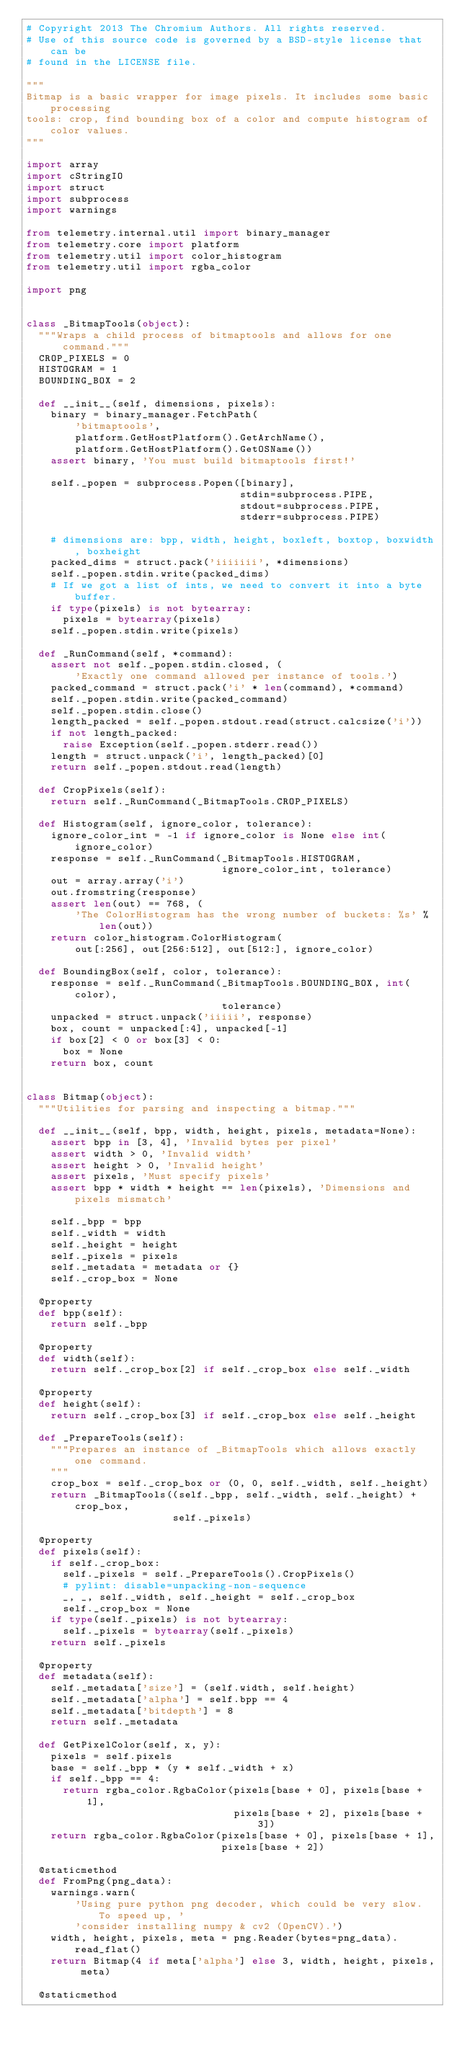<code> <loc_0><loc_0><loc_500><loc_500><_Python_># Copyright 2013 The Chromium Authors. All rights reserved.
# Use of this source code is governed by a BSD-style license that can be
# found in the LICENSE file.

"""
Bitmap is a basic wrapper for image pixels. It includes some basic processing
tools: crop, find bounding box of a color and compute histogram of color values.
"""

import array
import cStringIO
import struct
import subprocess
import warnings

from telemetry.internal.util import binary_manager
from telemetry.core import platform
from telemetry.util import color_histogram
from telemetry.util import rgba_color

import png


class _BitmapTools(object):
  """Wraps a child process of bitmaptools and allows for one command."""
  CROP_PIXELS = 0
  HISTOGRAM = 1
  BOUNDING_BOX = 2

  def __init__(self, dimensions, pixels):
    binary = binary_manager.FetchPath(
        'bitmaptools',
        platform.GetHostPlatform().GetArchName(),
        platform.GetHostPlatform().GetOSName())
    assert binary, 'You must build bitmaptools first!'

    self._popen = subprocess.Popen([binary],
                                   stdin=subprocess.PIPE,
                                   stdout=subprocess.PIPE,
                                   stderr=subprocess.PIPE)

    # dimensions are: bpp, width, height, boxleft, boxtop, boxwidth, boxheight
    packed_dims = struct.pack('iiiiiii', *dimensions)
    self._popen.stdin.write(packed_dims)
    # If we got a list of ints, we need to convert it into a byte buffer.
    if type(pixels) is not bytearray:
      pixels = bytearray(pixels)
    self._popen.stdin.write(pixels)

  def _RunCommand(self, *command):
    assert not self._popen.stdin.closed, (
        'Exactly one command allowed per instance of tools.')
    packed_command = struct.pack('i' * len(command), *command)
    self._popen.stdin.write(packed_command)
    self._popen.stdin.close()
    length_packed = self._popen.stdout.read(struct.calcsize('i'))
    if not length_packed:
      raise Exception(self._popen.stderr.read())
    length = struct.unpack('i', length_packed)[0]
    return self._popen.stdout.read(length)

  def CropPixels(self):
    return self._RunCommand(_BitmapTools.CROP_PIXELS)

  def Histogram(self, ignore_color, tolerance):
    ignore_color_int = -1 if ignore_color is None else int(ignore_color)
    response = self._RunCommand(_BitmapTools.HISTOGRAM,
                                ignore_color_int, tolerance)
    out = array.array('i')
    out.fromstring(response)
    assert len(out) == 768, (
        'The ColorHistogram has the wrong number of buckets: %s' % len(out))
    return color_histogram.ColorHistogram(
        out[:256], out[256:512], out[512:], ignore_color)

  def BoundingBox(self, color, tolerance):
    response = self._RunCommand(_BitmapTools.BOUNDING_BOX, int(color),
                                tolerance)
    unpacked = struct.unpack('iiiii', response)
    box, count = unpacked[:4], unpacked[-1]
    if box[2] < 0 or box[3] < 0:
      box = None
    return box, count


class Bitmap(object):
  """Utilities for parsing and inspecting a bitmap."""

  def __init__(self, bpp, width, height, pixels, metadata=None):
    assert bpp in [3, 4], 'Invalid bytes per pixel'
    assert width > 0, 'Invalid width'
    assert height > 0, 'Invalid height'
    assert pixels, 'Must specify pixels'
    assert bpp * width * height == len(pixels), 'Dimensions and pixels mismatch'

    self._bpp = bpp
    self._width = width
    self._height = height
    self._pixels = pixels
    self._metadata = metadata or {}
    self._crop_box = None

  @property
  def bpp(self):
    return self._bpp

  @property
  def width(self):
    return self._crop_box[2] if self._crop_box else self._width

  @property
  def height(self):
    return self._crop_box[3] if self._crop_box else self._height

  def _PrepareTools(self):
    """Prepares an instance of _BitmapTools which allows exactly one command.
    """
    crop_box = self._crop_box or (0, 0, self._width, self._height)
    return _BitmapTools((self._bpp, self._width, self._height) + crop_box,
                        self._pixels)

  @property
  def pixels(self):
    if self._crop_box:
      self._pixels = self._PrepareTools().CropPixels()
      # pylint: disable=unpacking-non-sequence
      _, _, self._width, self._height = self._crop_box
      self._crop_box = None
    if type(self._pixels) is not bytearray:
      self._pixels = bytearray(self._pixels)
    return self._pixels

  @property
  def metadata(self):
    self._metadata['size'] = (self.width, self.height)
    self._metadata['alpha'] = self.bpp == 4
    self._metadata['bitdepth'] = 8
    return self._metadata

  def GetPixelColor(self, x, y):
    pixels = self.pixels
    base = self._bpp * (y * self._width + x)
    if self._bpp == 4:
      return rgba_color.RgbaColor(pixels[base + 0], pixels[base + 1],
                                  pixels[base + 2], pixels[base + 3])
    return rgba_color.RgbaColor(pixels[base + 0], pixels[base + 1],
                                pixels[base + 2])

  @staticmethod
  def FromPng(png_data):
    warnings.warn(
        'Using pure python png decoder, which could be very slow. To speed up, '
        'consider installing numpy & cv2 (OpenCV).')
    width, height, pixels, meta = png.Reader(bytes=png_data).read_flat()
    return Bitmap(4 if meta['alpha'] else 3, width, height, pixels, meta)

  @staticmethod</code> 